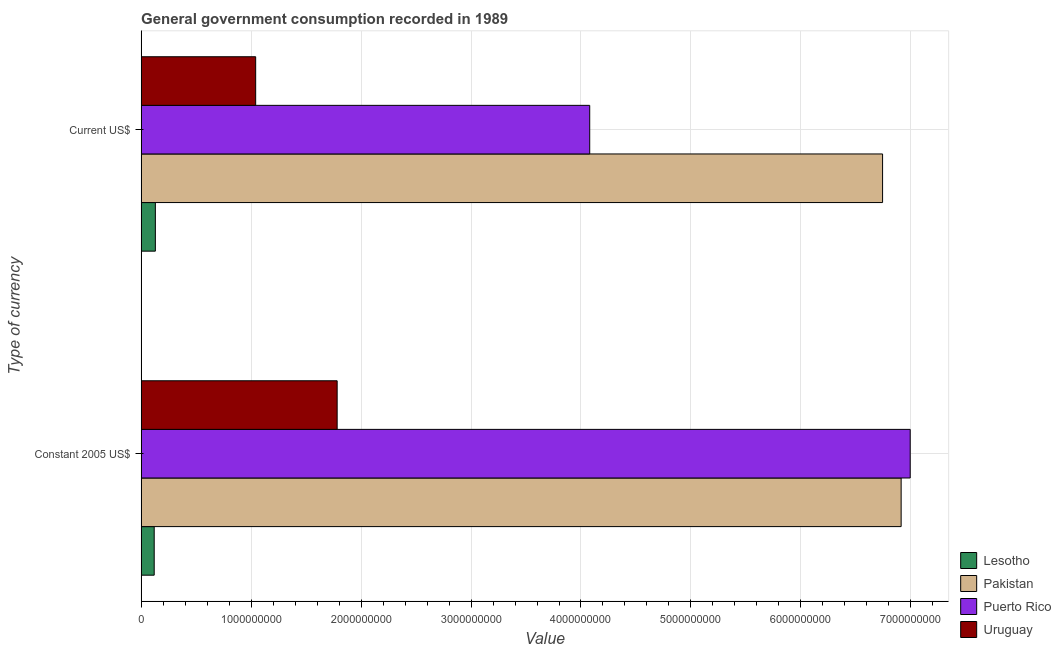How many groups of bars are there?
Ensure brevity in your answer.  2. Are the number of bars on each tick of the Y-axis equal?
Provide a succinct answer. Yes. How many bars are there on the 1st tick from the top?
Give a very brief answer. 4. How many bars are there on the 1st tick from the bottom?
Your response must be concise. 4. What is the label of the 1st group of bars from the top?
Provide a succinct answer. Current US$. What is the value consumed in current us$ in Uruguay?
Make the answer very short. 1.04e+09. Across all countries, what is the maximum value consumed in constant 2005 us$?
Provide a succinct answer. 6.99e+09. Across all countries, what is the minimum value consumed in current us$?
Ensure brevity in your answer.  1.29e+08. In which country was the value consumed in constant 2005 us$ maximum?
Your answer should be compact. Puerto Rico. In which country was the value consumed in current us$ minimum?
Ensure brevity in your answer.  Lesotho. What is the total value consumed in constant 2005 us$ in the graph?
Make the answer very short. 1.58e+1. What is the difference between the value consumed in constant 2005 us$ in Puerto Rico and that in Uruguay?
Keep it short and to the point. 5.21e+09. What is the difference between the value consumed in current us$ in Lesotho and the value consumed in constant 2005 us$ in Puerto Rico?
Your response must be concise. -6.86e+09. What is the average value consumed in current us$ per country?
Your answer should be compact. 3.00e+09. What is the difference between the value consumed in constant 2005 us$ and value consumed in current us$ in Pakistan?
Your response must be concise. 1.69e+08. What is the ratio of the value consumed in current us$ in Pakistan to that in Uruguay?
Offer a very short reply. 6.47. In how many countries, is the value consumed in current us$ greater than the average value consumed in current us$ taken over all countries?
Your response must be concise. 2. What does the 1st bar from the top in Constant 2005 US$ represents?
Make the answer very short. Uruguay. What does the 2nd bar from the bottom in Constant 2005 US$ represents?
Make the answer very short. Pakistan. Are all the bars in the graph horizontal?
Provide a succinct answer. Yes. How many countries are there in the graph?
Your answer should be compact. 4. Does the graph contain any zero values?
Offer a very short reply. No. Where does the legend appear in the graph?
Ensure brevity in your answer.  Bottom right. How are the legend labels stacked?
Provide a succinct answer. Vertical. What is the title of the graph?
Offer a very short reply. General government consumption recorded in 1989. Does "Syrian Arab Republic" appear as one of the legend labels in the graph?
Your answer should be very brief. No. What is the label or title of the X-axis?
Keep it short and to the point. Value. What is the label or title of the Y-axis?
Your answer should be compact. Type of currency. What is the Value in Lesotho in Constant 2005 US$?
Your answer should be compact. 1.19e+08. What is the Value in Pakistan in Constant 2005 US$?
Provide a succinct answer. 6.91e+09. What is the Value of Puerto Rico in Constant 2005 US$?
Give a very brief answer. 6.99e+09. What is the Value of Uruguay in Constant 2005 US$?
Your response must be concise. 1.78e+09. What is the Value in Lesotho in Current US$?
Offer a very short reply. 1.29e+08. What is the Value of Pakistan in Current US$?
Offer a terse response. 6.74e+09. What is the Value in Puerto Rico in Current US$?
Ensure brevity in your answer.  4.08e+09. What is the Value of Uruguay in Current US$?
Provide a succinct answer. 1.04e+09. Across all Type of currency, what is the maximum Value of Lesotho?
Your answer should be compact. 1.29e+08. Across all Type of currency, what is the maximum Value in Pakistan?
Keep it short and to the point. 6.91e+09. Across all Type of currency, what is the maximum Value of Puerto Rico?
Keep it short and to the point. 6.99e+09. Across all Type of currency, what is the maximum Value of Uruguay?
Provide a short and direct response. 1.78e+09. Across all Type of currency, what is the minimum Value in Lesotho?
Your response must be concise. 1.19e+08. Across all Type of currency, what is the minimum Value in Pakistan?
Offer a terse response. 6.74e+09. Across all Type of currency, what is the minimum Value in Puerto Rico?
Give a very brief answer. 4.08e+09. Across all Type of currency, what is the minimum Value in Uruguay?
Your response must be concise. 1.04e+09. What is the total Value in Lesotho in the graph?
Offer a very short reply. 2.48e+08. What is the total Value in Pakistan in the graph?
Your answer should be compact. 1.37e+1. What is the total Value in Puerto Rico in the graph?
Your response must be concise. 1.11e+1. What is the total Value in Uruguay in the graph?
Give a very brief answer. 2.82e+09. What is the difference between the Value in Lesotho in Constant 2005 US$ and that in Current US$?
Give a very brief answer. -1.05e+07. What is the difference between the Value in Pakistan in Constant 2005 US$ and that in Current US$?
Offer a terse response. 1.69e+08. What is the difference between the Value of Puerto Rico in Constant 2005 US$ and that in Current US$?
Give a very brief answer. 2.91e+09. What is the difference between the Value of Uruguay in Constant 2005 US$ and that in Current US$?
Your response must be concise. 7.41e+08. What is the difference between the Value in Lesotho in Constant 2005 US$ and the Value in Pakistan in Current US$?
Provide a short and direct response. -6.62e+09. What is the difference between the Value of Lesotho in Constant 2005 US$ and the Value of Puerto Rico in Current US$?
Ensure brevity in your answer.  -3.96e+09. What is the difference between the Value in Lesotho in Constant 2005 US$ and the Value in Uruguay in Current US$?
Provide a short and direct response. -9.23e+08. What is the difference between the Value in Pakistan in Constant 2005 US$ and the Value in Puerto Rico in Current US$?
Your answer should be compact. 2.83e+09. What is the difference between the Value in Pakistan in Constant 2005 US$ and the Value in Uruguay in Current US$?
Your response must be concise. 5.87e+09. What is the difference between the Value in Puerto Rico in Constant 2005 US$ and the Value in Uruguay in Current US$?
Provide a short and direct response. 5.95e+09. What is the average Value of Lesotho per Type of currency?
Offer a very short reply. 1.24e+08. What is the average Value in Pakistan per Type of currency?
Offer a terse response. 6.83e+09. What is the average Value of Puerto Rico per Type of currency?
Your answer should be very brief. 5.54e+09. What is the average Value in Uruguay per Type of currency?
Your answer should be compact. 1.41e+09. What is the difference between the Value of Lesotho and Value of Pakistan in Constant 2005 US$?
Provide a succinct answer. -6.79e+09. What is the difference between the Value in Lesotho and Value in Puerto Rico in Constant 2005 US$?
Your response must be concise. -6.88e+09. What is the difference between the Value of Lesotho and Value of Uruguay in Constant 2005 US$?
Your answer should be compact. -1.66e+09. What is the difference between the Value in Pakistan and Value in Puerto Rico in Constant 2005 US$?
Offer a terse response. -8.25e+07. What is the difference between the Value of Pakistan and Value of Uruguay in Constant 2005 US$?
Provide a short and direct response. 5.13e+09. What is the difference between the Value of Puerto Rico and Value of Uruguay in Constant 2005 US$?
Your answer should be very brief. 5.21e+09. What is the difference between the Value in Lesotho and Value in Pakistan in Current US$?
Your answer should be very brief. -6.61e+09. What is the difference between the Value of Lesotho and Value of Puerto Rico in Current US$?
Make the answer very short. -3.95e+09. What is the difference between the Value in Lesotho and Value in Uruguay in Current US$?
Provide a short and direct response. -9.12e+08. What is the difference between the Value in Pakistan and Value in Puerto Rico in Current US$?
Give a very brief answer. 2.66e+09. What is the difference between the Value in Pakistan and Value in Uruguay in Current US$?
Your response must be concise. 5.70e+09. What is the difference between the Value in Puerto Rico and Value in Uruguay in Current US$?
Offer a very short reply. 3.04e+09. What is the ratio of the Value of Lesotho in Constant 2005 US$ to that in Current US$?
Your response must be concise. 0.92. What is the ratio of the Value in Puerto Rico in Constant 2005 US$ to that in Current US$?
Give a very brief answer. 1.71. What is the ratio of the Value of Uruguay in Constant 2005 US$ to that in Current US$?
Provide a succinct answer. 1.71. What is the difference between the highest and the second highest Value in Lesotho?
Your answer should be very brief. 1.05e+07. What is the difference between the highest and the second highest Value in Pakistan?
Your response must be concise. 1.69e+08. What is the difference between the highest and the second highest Value of Puerto Rico?
Provide a short and direct response. 2.91e+09. What is the difference between the highest and the second highest Value of Uruguay?
Make the answer very short. 7.41e+08. What is the difference between the highest and the lowest Value of Lesotho?
Make the answer very short. 1.05e+07. What is the difference between the highest and the lowest Value of Pakistan?
Your answer should be very brief. 1.69e+08. What is the difference between the highest and the lowest Value in Puerto Rico?
Ensure brevity in your answer.  2.91e+09. What is the difference between the highest and the lowest Value of Uruguay?
Your response must be concise. 7.41e+08. 